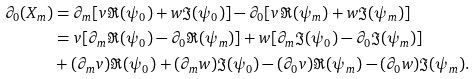<formula> <loc_0><loc_0><loc_500><loc_500>\partial _ { 0 } ( X _ { m } ) & = \partial _ { m } [ v \Re ( \psi _ { 0 } ) + w \Im ( \psi _ { 0 } ) ] - \partial _ { 0 } [ v \Re ( \psi _ { m } ) + w \Im ( \psi _ { m } ) ] \\ & = v [ \partial _ { m } \Re ( \psi _ { 0 } ) - \partial _ { 0 } \Re ( \psi _ { m } ) ] + w [ \partial _ { m } \Im ( \psi _ { 0 } ) - \partial _ { 0 } \Im ( \psi _ { m } ) ] \\ & + ( \partial _ { m } v ) \Re ( \psi _ { 0 } ) + ( \partial _ { m } w ) \Im ( \psi _ { 0 } ) - ( \partial _ { 0 } v ) \Re ( \psi _ { m } ) - ( \partial _ { 0 } w ) \Im ( \psi _ { m } ) .</formula> 